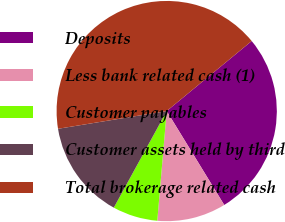<chart> <loc_0><loc_0><loc_500><loc_500><pie_chart><fcel>Deposits<fcel>Less bank related cash (1)<fcel>Customer payables<fcel>Customer assets held by third<fcel>Total brokerage related cash<nl><fcel>27.22%<fcel>10.11%<fcel>6.61%<fcel>14.45%<fcel>41.6%<nl></chart> 